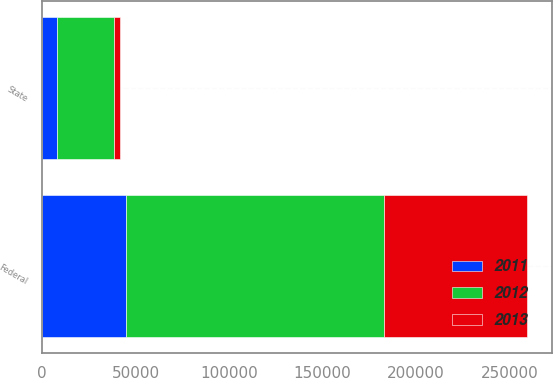<chart> <loc_0><loc_0><loc_500><loc_500><stacked_bar_chart><ecel><fcel>Federal<fcel>State<nl><fcel>2012<fcel>137675<fcel>30352<nl><fcel>2013<fcel>76599<fcel>3066<nl><fcel>2011<fcel>45112<fcel>8004<nl></chart> 